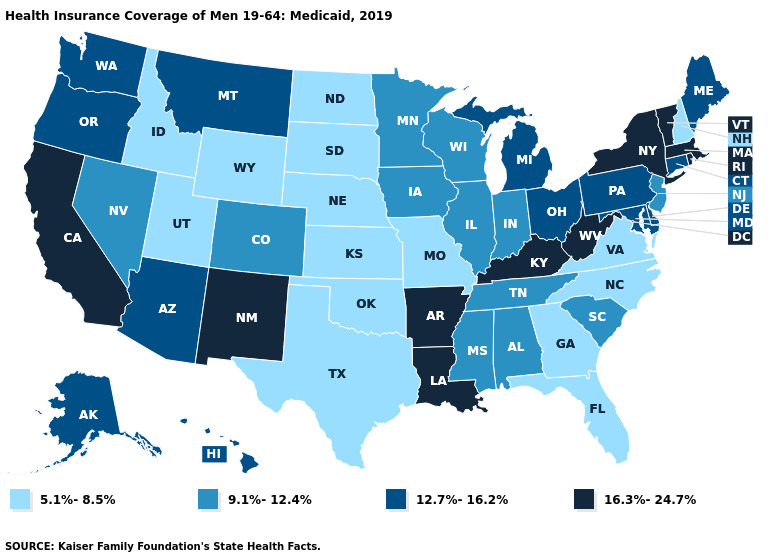What is the value of North Carolina?
Give a very brief answer. 5.1%-8.5%. What is the value of New Hampshire?
Quick response, please. 5.1%-8.5%. What is the value of Tennessee?
Write a very short answer. 9.1%-12.4%. Among the states that border New Mexico , which have the highest value?
Give a very brief answer. Arizona. Name the states that have a value in the range 12.7%-16.2%?
Concise answer only. Alaska, Arizona, Connecticut, Delaware, Hawaii, Maine, Maryland, Michigan, Montana, Ohio, Oregon, Pennsylvania, Washington. What is the value of Washington?
Be succinct. 12.7%-16.2%. Name the states that have a value in the range 9.1%-12.4%?
Give a very brief answer. Alabama, Colorado, Illinois, Indiana, Iowa, Minnesota, Mississippi, Nevada, New Jersey, South Carolina, Tennessee, Wisconsin. What is the value of New Hampshire?
Answer briefly. 5.1%-8.5%. Among the states that border Wisconsin , does Minnesota have the highest value?
Keep it brief. No. What is the value of Indiana?
Be succinct. 9.1%-12.4%. What is the value of Oregon?
Short answer required. 12.7%-16.2%. What is the value of Michigan?
Concise answer only. 12.7%-16.2%. Name the states that have a value in the range 9.1%-12.4%?
Quick response, please. Alabama, Colorado, Illinois, Indiana, Iowa, Minnesota, Mississippi, Nevada, New Jersey, South Carolina, Tennessee, Wisconsin. Name the states that have a value in the range 16.3%-24.7%?
Answer briefly. Arkansas, California, Kentucky, Louisiana, Massachusetts, New Mexico, New York, Rhode Island, Vermont, West Virginia. 